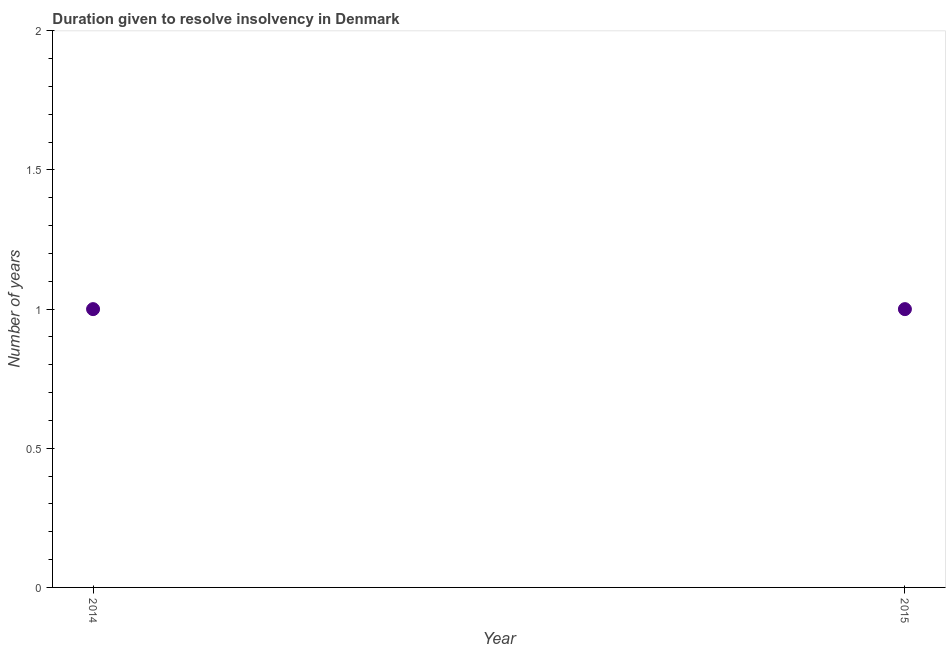What is the number of years to resolve insolvency in 2014?
Your answer should be very brief. 1. Across all years, what is the maximum number of years to resolve insolvency?
Your answer should be very brief. 1. Across all years, what is the minimum number of years to resolve insolvency?
Offer a terse response. 1. In which year was the number of years to resolve insolvency minimum?
Ensure brevity in your answer.  2014. What is the sum of the number of years to resolve insolvency?
Your response must be concise. 2. What is the average number of years to resolve insolvency per year?
Provide a short and direct response. 1. What is the median number of years to resolve insolvency?
Provide a short and direct response. 1. Do a majority of the years between 2015 and 2014 (inclusive) have number of years to resolve insolvency greater than 1.3 ?
Provide a short and direct response. No. Is the number of years to resolve insolvency in 2014 less than that in 2015?
Your response must be concise. No. How many dotlines are there?
Offer a very short reply. 1. How many years are there in the graph?
Give a very brief answer. 2. Are the values on the major ticks of Y-axis written in scientific E-notation?
Provide a short and direct response. No. What is the title of the graph?
Ensure brevity in your answer.  Duration given to resolve insolvency in Denmark. What is the label or title of the Y-axis?
Offer a terse response. Number of years. What is the Number of years in 2014?
Offer a terse response. 1. What is the ratio of the Number of years in 2014 to that in 2015?
Ensure brevity in your answer.  1. 